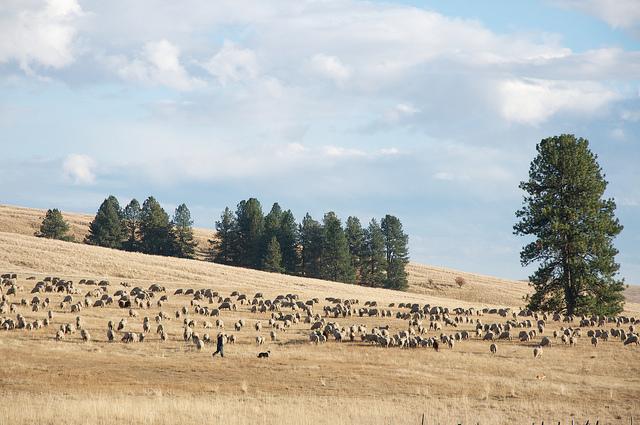How many birds are standing in this field?
Answer briefly. 100. What color is the ground?
Concise answer only. Brown. Are there just animals in the picture or is there people to?
Quick response, please. Both. 